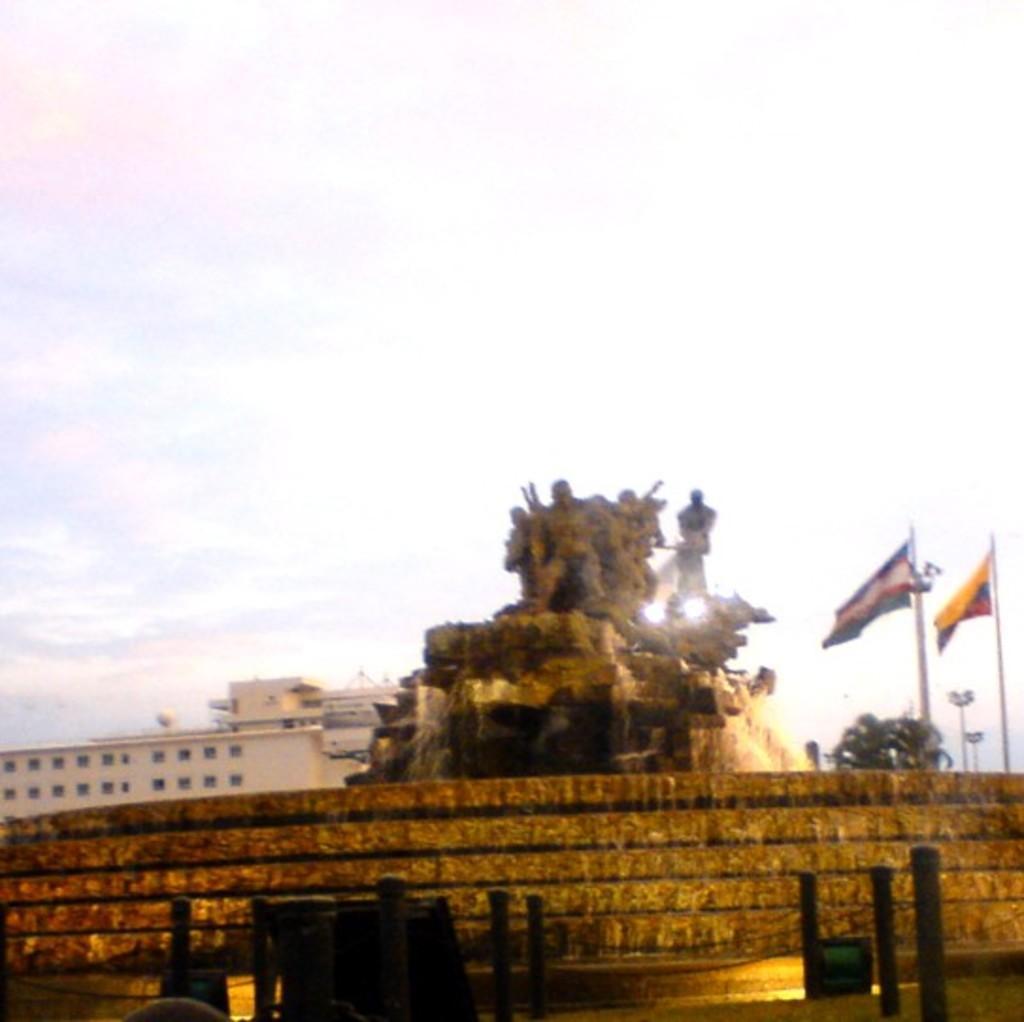Describe this image in one or two sentences. In the image there is a wall in the foreground and behind the wall there are some sculptures and on the right side there are flags, behind the flags there is a tree and in the background there is a building. 